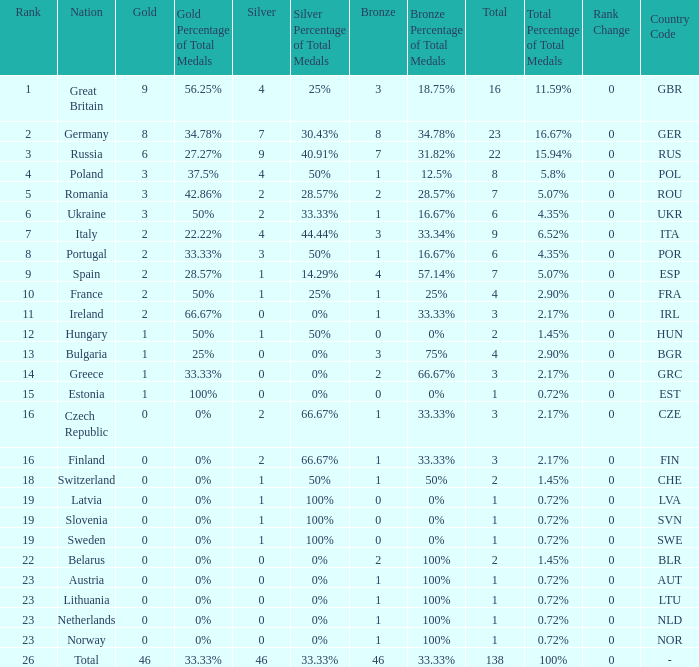When the total is larger than 1,and the bronze is less than 3, and silver larger than 2, and a gold larger than 2, what is the nation? Poland. 